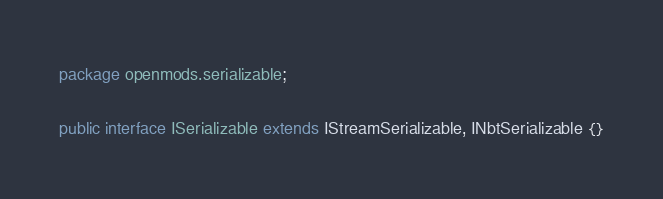<code> <loc_0><loc_0><loc_500><loc_500><_Java_>package openmods.serializable;

public interface ISerializable extends IStreamSerializable, INbtSerializable {}
</code> 